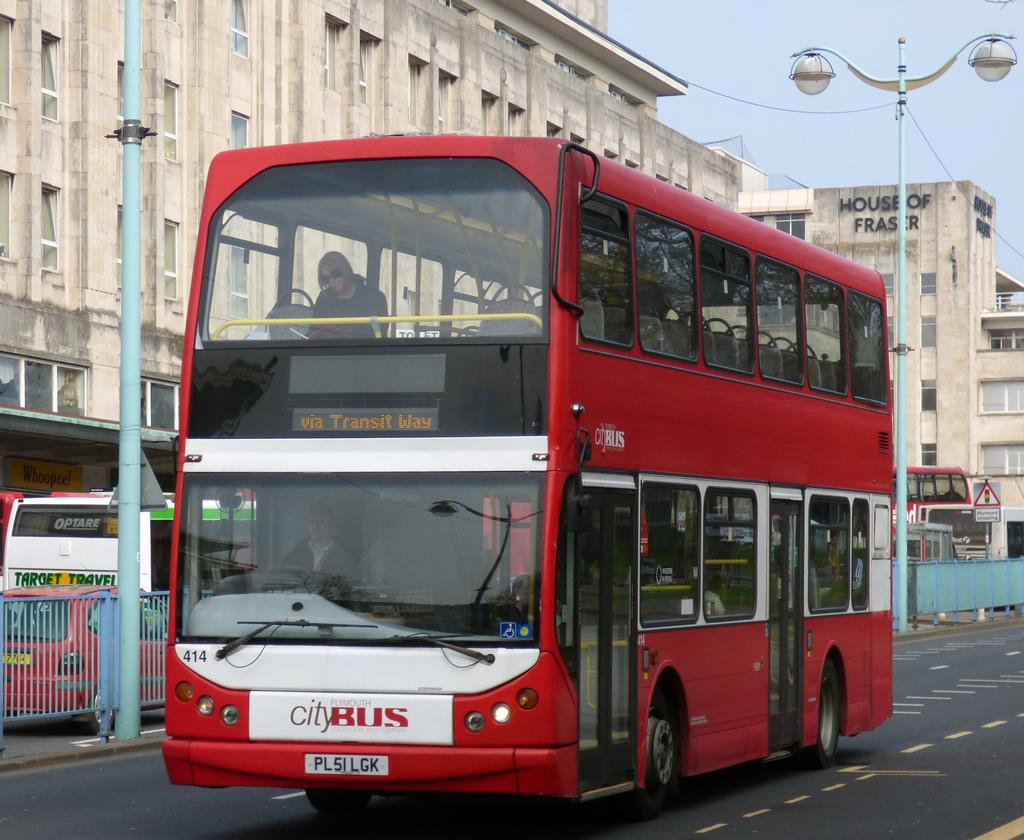<image>
Provide a brief description of the given image. Red and white double decker bus that reads "via Transit Way". 